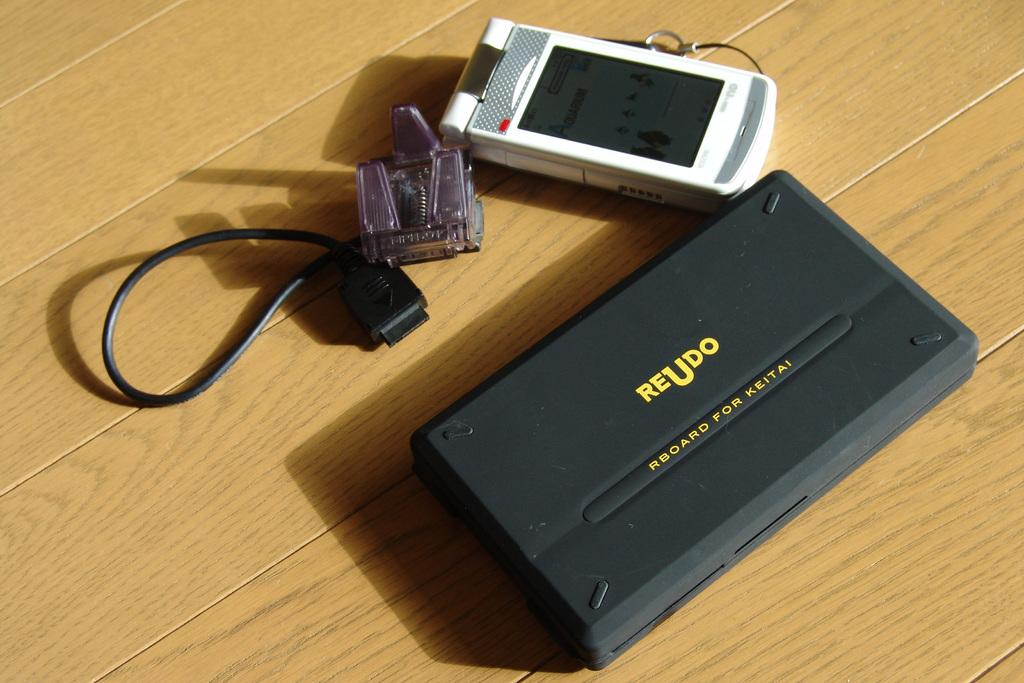<image>
Describe the image concisely. A black unit has Reudo and Rboard for keitai in yellow letters. 